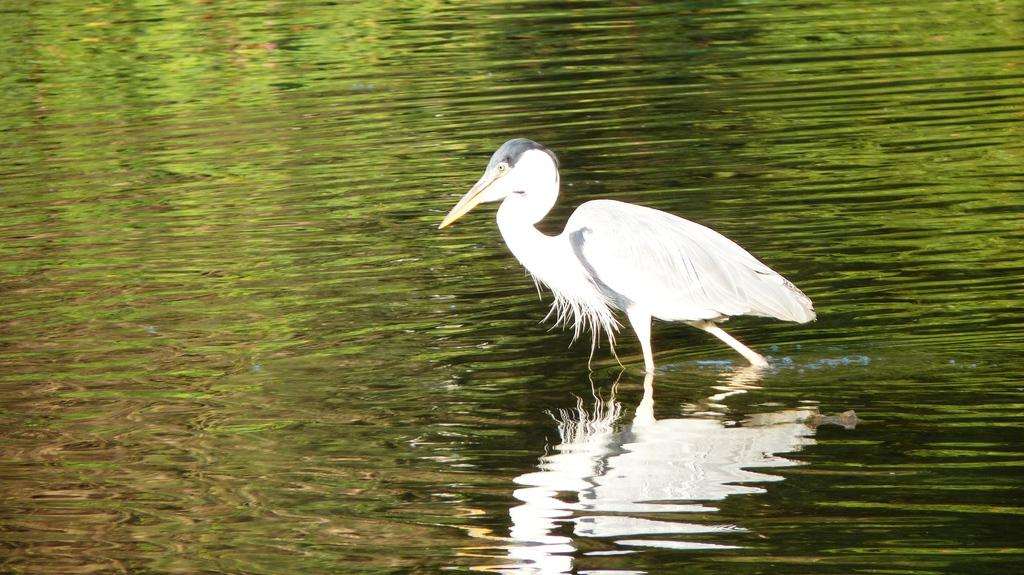What is the main subject of the image? There is a bird in the center of the image. Where is the bird located? The bird is in the water. Can you describe any additional features of the bird in the image? There is a reflection of the bird on the water. How many pizzas are visible in the image? There are no pizzas present in the image. What type of wound can be seen on the bird in the image? There is no wound visible on the bird in the image. 